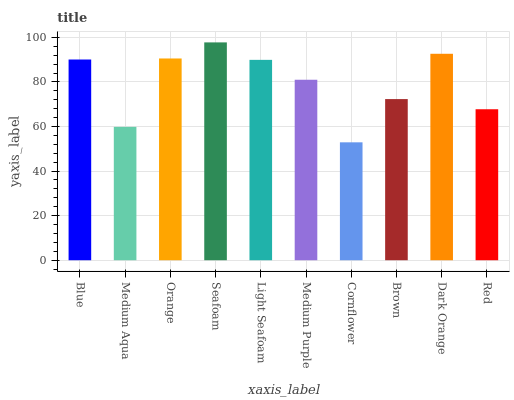Is Cornflower the minimum?
Answer yes or no. Yes. Is Seafoam the maximum?
Answer yes or no. Yes. Is Medium Aqua the minimum?
Answer yes or no. No. Is Medium Aqua the maximum?
Answer yes or no. No. Is Blue greater than Medium Aqua?
Answer yes or no. Yes. Is Medium Aqua less than Blue?
Answer yes or no. Yes. Is Medium Aqua greater than Blue?
Answer yes or no. No. Is Blue less than Medium Aqua?
Answer yes or no. No. Is Light Seafoam the high median?
Answer yes or no. Yes. Is Medium Purple the low median?
Answer yes or no. Yes. Is Blue the high median?
Answer yes or no. No. Is Light Seafoam the low median?
Answer yes or no. No. 